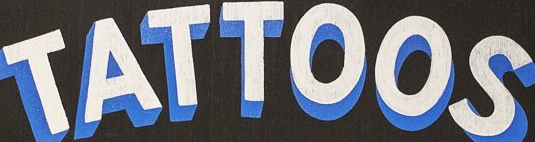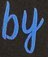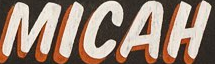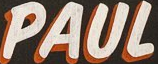Transcribe the words shown in these images in order, separated by a semicolon. TATTOOS; by; MICAH; PAUL 